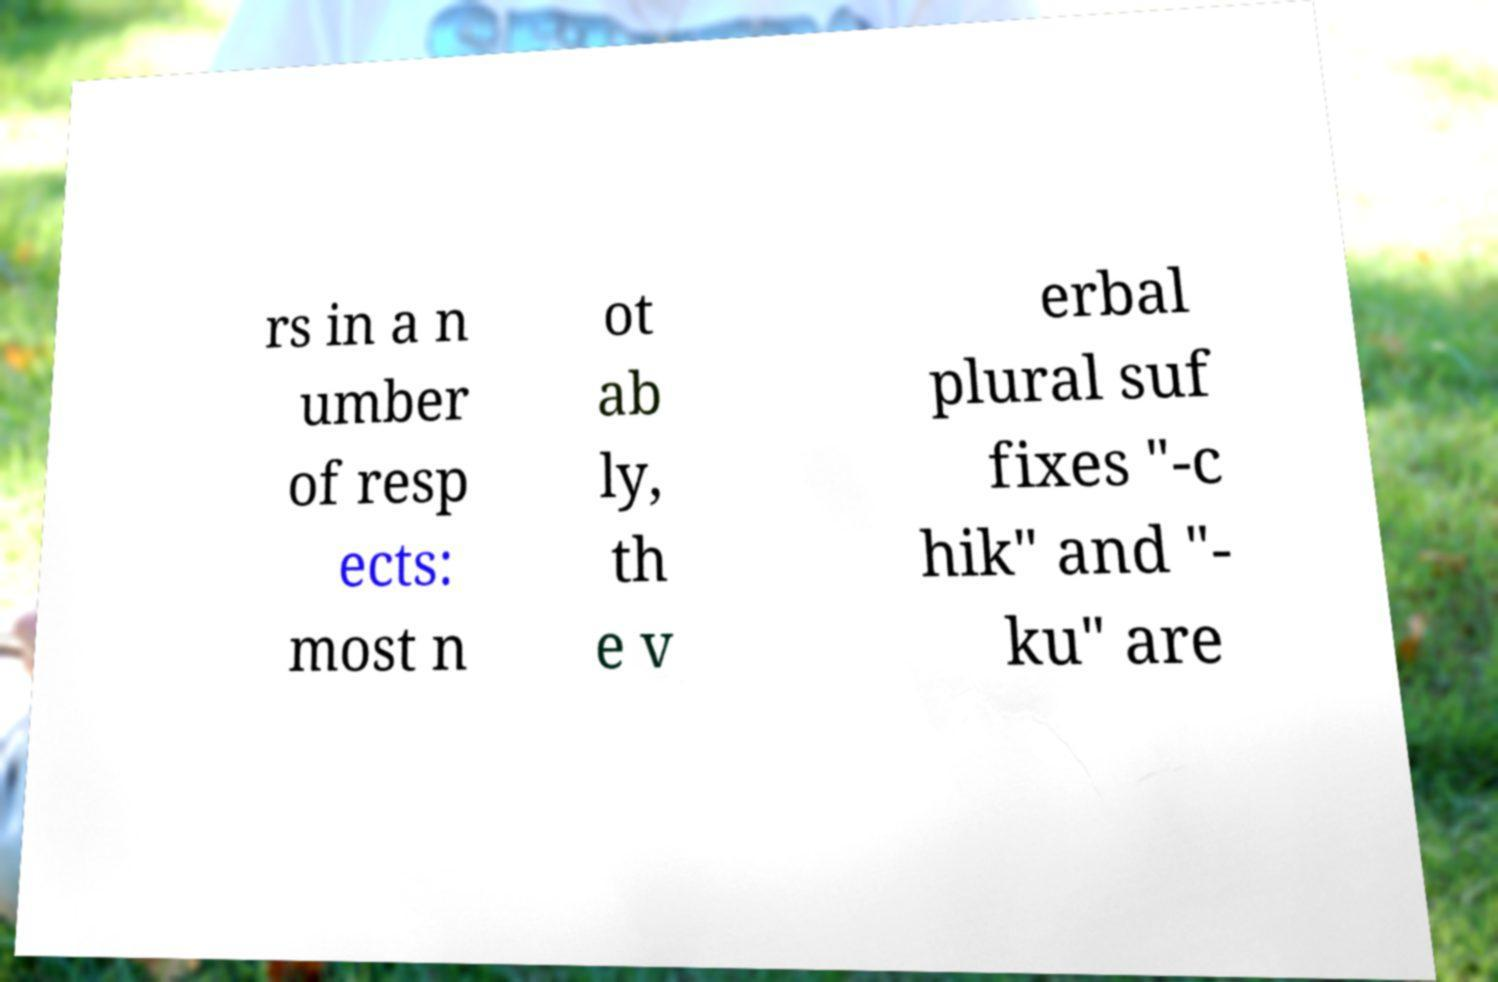Please identify and transcribe the text found in this image. rs in a n umber of resp ects: most n ot ab ly, th e v erbal plural suf fixes "-c hik" and "- ku" are 